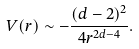Convert formula to latex. <formula><loc_0><loc_0><loc_500><loc_500>V ( r ) \sim - \frac { ( d - 2 ) ^ { 2 } } { 4 r ^ { 2 d - 4 } } .</formula> 